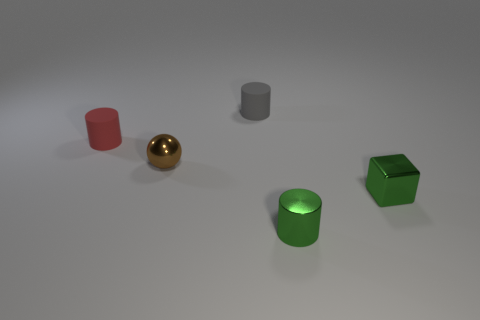Subtract all tiny rubber cylinders. How many cylinders are left? 1 Add 2 matte objects. How many objects exist? 7 Subtract all cylinders. How many objects are left? 2 Subtract 1 balls. How many balls are left? 0 Add 3 cylinders. How many cylinders are left? 6 Add 1 tiny green shiny cubes. How many tiny green shiny cubes exist? 2 Subtract 0 brown blocks. How many objects are left? 5 Subtract all yellow balls. Subtract all yellow blocks. How many balls are left? 1 Subtract all big shiny balls. Subtract all small cubes. How many objects are left? 4 